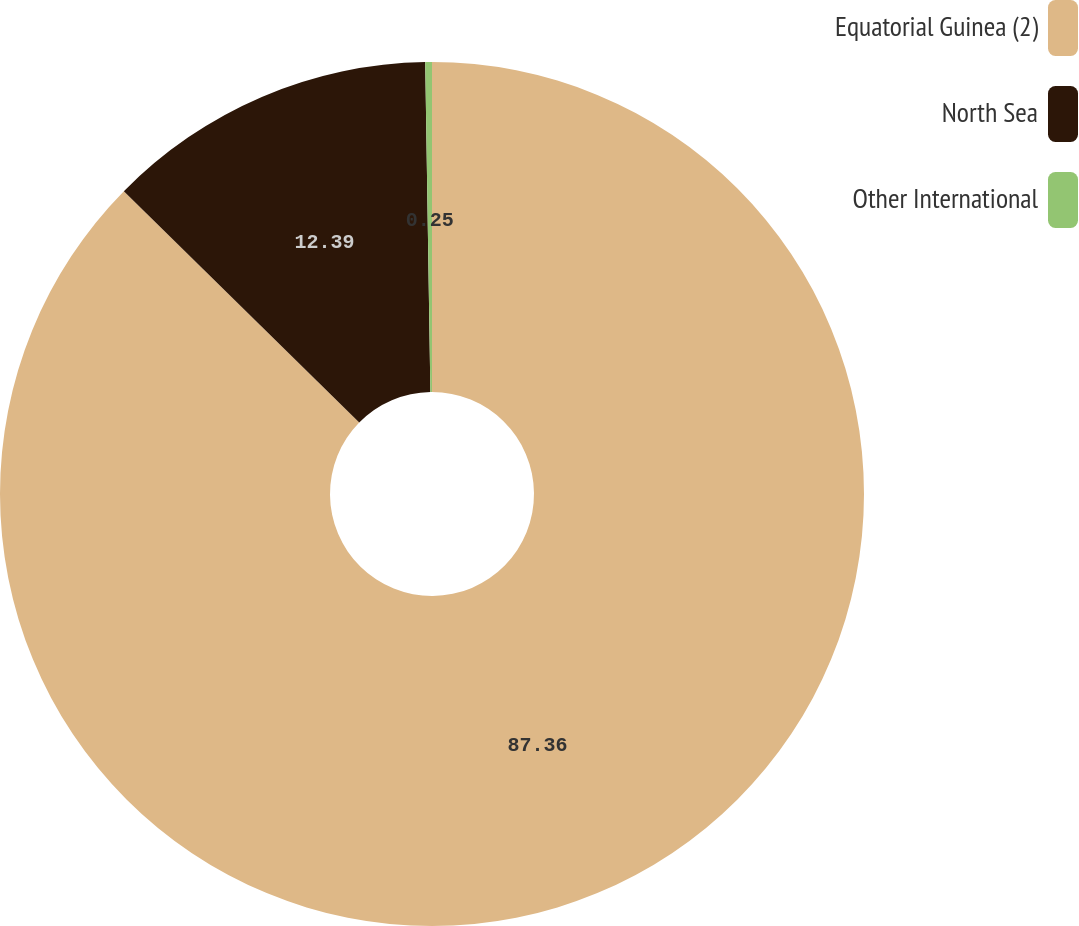<chart> <loc_0><loc_0><loc_500><loc_500><pie_chart><fcel>Equatorial Guinea (2)<fcel>North Sea<fcel>Other International<nl><fcel>87.36%<fcel>12.39%<fcel>0.25%<nl></chart> 